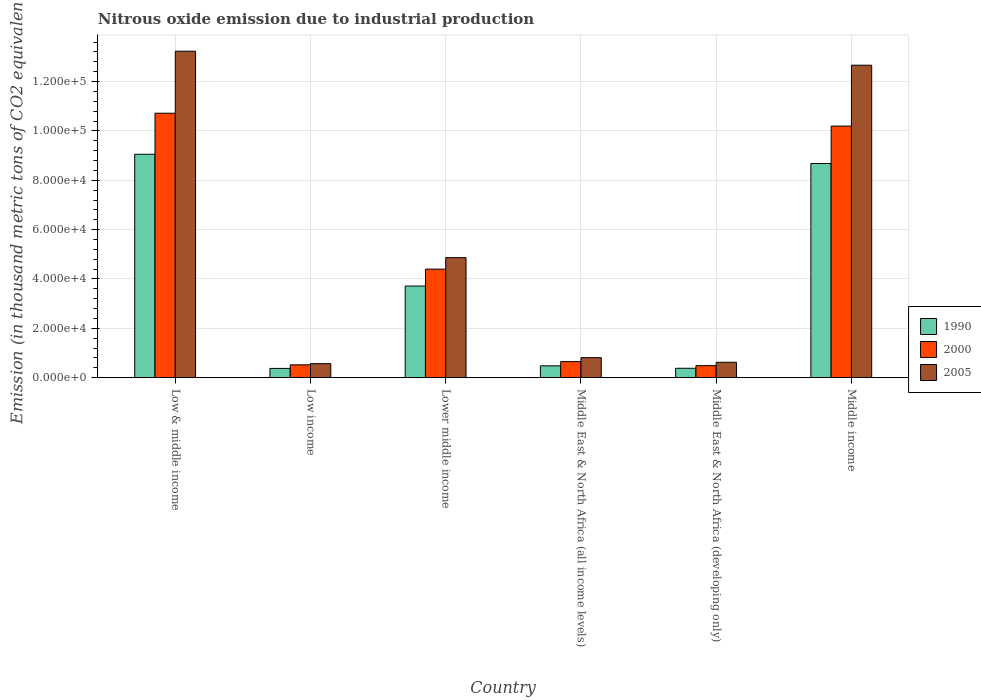Are the number of bars per tick equal to the number of legend labels?
Your answer should be compact. Yes. Are the number of bars on each tick of the X-axis equal?
Your answer should be compact. Yes. How many bars are there on the 5th tick from the left?
Make the answer very short. 3. What is the label of the 2nd group of bars from the left?
Offer a very short reply. Low income. In how many cases, is the number of bars for a given country not equal to the number of legend labels?
Your answer should be very brief. 0. What is the amount of nitrous oxide emitted in 2000 in Low & middle income?
Ensure brevity in your answer.  1.07e+05. Across all countries, what is the maximum amount of nitrous oxide emitted in 1990?
Your answer should be compact. 9.05e+04. Across all countries, what is the minimum amount of nitrous oxide emitted in 2005?
Offer a terse response. 5680.8. In which country was the amount of nitrous oxide emitted in 2000 minimum?
Provide a succinct answer. Middle East & North Africa (developing only). What is the total amount of nitrous oxide emitted in 2000 in the graph?
Ensure brevity in your answer.  2.70e+05. What is the difference between the amount of nitrous oxide emitted in 2000 in Low & middle income and that in Middle East & North Africa (all income levels)?
Give a very brief answer. 1.01e+05. What is the difference between the amount of nitrous oxide emitted in 2000 in Middle East & North Africa (all income levels) and the amount of nitrous oxide emitted in 2005 in Lower middle income?
Your answer should be compact. -4.22e+04. What is the average amount of nitrous oxide emitted in 2005 per country?
Offer a very short reply. 5.46e+04. What is the difference between the amount of nitrous oxide emitted of/in 2000 and amount of nitrous oxide emitted of/in 1990 in Middle income?
Your answer should be very brief. 1.52e+04. What is the ratio of the amount of nitrous oxide emitted in 1990 in Low & middle income to that in Lower middle income?
Offer a very short reply. 2.44. What is the difference between the highest and the second highest amount of nitrous oxide emitted in 1990?
Ensure brevity in your answer.  3751.3. What is the difference between the highest and the lowest amount of nitrous oxide emitted in 1990?
Your answer should be very brief. 8.68e+04. Is the sum of the amount of nitrous oxide emitted in 1990 in Low & middle income and Middle East & North Africa (all income levels) greater than the maximum amount of nitrous oxide emitted in 2005 across all countries?
Offer a terse response. No. Is it the case that in every country, the sum of the amount of nitrous oxide emitted in 2000 and amount of nitrous oxide emitted in 2005 is greater than the amount of nitrous oxide emitted in 1990?
Ensure brevity in your answer.  Yes. How many bars are there?
Offer a very short reply. 18. Are all the bars in the graph horizontal?
Your answer should be compact. No. How many countries are there in the graph?
Offer a terse response. 6. What is the difference between two consecutive major ticks on the Y-axis?
Keep it short and to the point. 2.00e+04. Are the values on the major ticks of Y-axis written in scientific E-notation?
Provide a succinct answer. Yes. Does the graph contain grids?
Your answer should be very brief. Yes. Where does the legend appear in the graph?
Provide a succinct answer. Center right. How many legend labels are there?
Your answer should be very brief. 3. What is the title of the graph?
Keep it short and to the point. Nitrous oxide emission due to industrial production. Does "1970" appear as one of the legend labels in the graph?
Your answer should be compact. No. What is the label or title of the X-axis?
Keep it short and to the point. Country. What is the label or title of the Y-axis?
Your answer should be compact. Emission (in thousand metric tons of CO2 equivalent). What is the Emission (in thousand metric tons of CO2 equivalent) in 1990 in Low & middle income?
Give a very brief answer. 9.05e+04. What is the Emission (in thousand metric tons of CO2 equivalent) of 2000 in Low & middle income?
Provide a succinct answer. 1.07e+05. What is the Emission (in thousand metric tons of CO2 equivalent) in 2005 in Low & middle income?
Give a very brief answer. 1.32e+05. What is the Emission (in thousand metric tons of CO2 equivalent) of 1990 in Low income?
Provide a succinct answer. 3751.3. What is the Emission (in thousand metric tons of CO2 equivalent) of 2000 in Low income?
Provide a short and direct response. 5201.5. What is the Emission (in thousand metric tons of CO2 equivalent) in 2005 in Low income?
Offer a terse response. 5680.8. What is the Emission (in thousand metric tons of CO2 equivalent) in 1990 in Lower middle income?
Provide a succinct answer. 3.71e+04. What is the Emission (in thousand metric tons of CO2 equivalent) of 2000 in Lower middle income?
Offer a terse response. 4.40e+04. What is the Emission (in thousand metric tons of CO2 equivalent) in 2005 in Lower middle income?
Provide a short and direct response. 4.87e+04. What is the Emission (in thousand metric tons of CO2 equivalent) in 1990 in Middle East & North Africa (all income levels)?
Make the answer very short. 4795.2. What is the Emission (in thousand metric tons of CO2 equivalent) of 2000 in Middle East & North Africa (all income levels)?
Your answer should be very brief. 6497. What is the Emission (in thousand metric tons of CO2 equivalent) of 2005 in Middle East & North Africa (all income levels)?
Your answer should be compact. 8118.6. What is the Emission (in thousand metric tons of CO2 equivalent) in 1990 in Middle East & North Africa (developing only)?
Keep it short and to the point. 3806.6. What is the Emission (in thousand metric tons of CO2 equivalent) in 2000 in Middle East & North Africa (developing only)?
Your response must be concise. 4882.9. What is the Emission (in thousand metric tons of CO2 equivalent) of 2005 in Middle East & North Africa (developing only)?
Your answer should be very brief. 6239.6. What is the Emission (in thousand metric tons of CO2 equivalent) in 1990 in Middle income?
Your answer should be very brief. 8.68e+04. What is the Emission (in thousand metric tons of CO2 equivalent) in 2000 in Middle income?
Provide a succinct answer. 1.02e+05. What is the Emission (in thousand metric tons of CO2 equivalent) of 2005 in Middle income?
Ensure brevity in your answer.  1.27e+05. Across all countries, what is the maximum Emission (in thousand metric tons of CO2 equivalent) of 1990?
Your answer should be compact. 9.05e+04. Across all countries, what is the maximum Emission (in thousand metric tons of CO2 equivalent) of 2000?
Keep it short and to the point. 1.07e+05. Across all countries, what is the maximum Emission (in thousand metric tons of CO2 equivalent) of 2005?
Your answer should be compact. 1.32e+05. Across all countries, what is the minimum Emission (in thousand metric tons of CO2 equivalent) of 1990?
Keep it short and to the point. 3751.3. Across all countries, what is the minimum Emission (in thousand metric tons of CO2 equivalent) of 2000?
Give a very brief answer. 4882.9. Across all countries, what is the minimum Emission (in thousand metric tons of CO2 equivalent) in 2005?
Make the answer very short. 5680.8. What is the total Emission (in thousand metric tons of CO2 equivalent) in 1990 in the graph?
Offer a terse response. 2.27e+05. What is the total Emission (in thousand metric tons of CO2 equivalent) of 2000 in the graph?
Give a very brief answer. 2.70e+05. What is the total Emission (in thousand metric tons of CO2 equivalent) in 2005 in the graph?
Keep it short and to the point. 3.28e+05. What is the difference between the Emission (in thousand metric tons of CO2 equivalent) in 1990 in Low & middle income and that in Low income?
Your answer should be compact. 8.68e+04. What is the difference between the Emission (in thousand metric tons of CO2 equivalent) in 2000 in Low & middle income and that in Low income?
Your answer should be compact. 1.02e+05. What is the difference between the Emission (in thousand metric tons of CO2 equivalent) in 2005 in Low & middle income and that in Low income?
Offer a very short reply. 1.27e+05. What is the difference between the Emission (in thousand metric tons of CO2 equivalent) in 1990 in Low & middle income and that in Lower middle income?
Your answer should be very brief. 5.34e+04. What is the difference between the Emission (in thousand metric tons of CO2 equivalent) of 2000 in Low & middle income and that in Lower middle income?
Provide a short and direct response. 6.32e+04. What is the difference between the Emission (in thousand metric tons of CO2 equivalent) in 2005 in Low & middle income and that in Lower middle income?
Your response must be concise. 8.37e+04. What is the difference between the Emission (in thousand metric tons of CO2 equivalent) in 1990 in Low & middle income and that in Middle East & North Africa (all income levels)?
Offer a very short reply. 8.57e+04. What is the difference between the Emission (in thousand metric tons of CO2 equivalent) of 2000 in Low & middle income and that in Middle East & North Africa (all income levels)?
Your answer should be compact. 1.01e+05. What is the difference between the Emission (in thousand metric tons of CO2 equivalent) in 2005 in Low & middle income and that in Middle East & North Africa (all income levels)?
Provide a succinct answer. 1.24e+05. What is the difference between the Emission (in thousand metric tons of CO2 equivalent) in 1990 in Low & middle income and that in Middle East & North Africa (developing only)?
Your response must be concise. 8.67e+04. What is the difference between the Emission (in thousand metric tons of CO2 equivalent) in 2000 in Low & middle income and that in Middle East & North Africa (developing only)?
Provide a short and direct response. 1.02e+05. What is the difference between the Emission (in thousand metric tons of CO2 equivalent) of 2005 in Low & middle income and that in Middle East & North Africa (developing only)?
Your response must be concise. 1.26e+05. What is the difference between the Emission (in thousand metric tons of CO2 equivalent) in 1990 in Low & middle income and that in Middle income?
Ensure brevity in your answer.  3751.3. What is the difference between the Emission (in thousand metric tons of CO2 equivalent) in 2000 in Low & middle income and that in Middle income?
Offer a terse response. 5201.5. What is the difference between the Emission (in thousand metric tons of CO2 equivalent) of 2005 in Low & middle income and that in Middle income?
Provide a succinct answer. 5680.8. What is the difference between the Emission (in thousand metric tons of CO2 equivalent) of 1990 in Low income and that in Lower middle income?
Make the answer very short. -3.34e+04. What is the difference between the Emission (in thousand metric tons of CO2 equivalent) in 2000 in Low income and that in Lower middle income?
Ensure brevity in your answer.  -3.88e+04. What is the difference between the Emission (in thousand metric tons of CO2 equivalent) in 2005 in Low income and that in Lower middle income?
Offer a terse response. -4.30e+04. What is the difference between the Emission (in thousand metric tons of CO2 equivalent) of 1990 in Low income and that in Middle East & North Africa (all income levels)?
Make the answer very short. -1043.9. What is the difference between the Emission (in thousand metric tons of CO2 equivalent) of 2000 in Low income and that in Middle East & North Africa (all income levels)?
Give a very brief answer. -1295.5. What is the difference between the Emission (in thousand metric tons of CO2 equivalent) in 2005 in Low income and that in Middle East & North Africa (all income levels)?
Your response must be concise. -2437.8. What is the difference between the Emission (in thousand metric tons of CO2 equivalent) of 1990 in Low income and that in Middle East & North Africa (developing only)?
Make the answer very short. -55.3. What is the difference between the Emission (in thousand metric tons of CO2 equivalent) of 2000 in Low income and that in Middle East & North Africa (developing only)?
Offer a terse response. 318.6. What is the difference between the Emission (in thousand metric tons of CO2 equivalent) in 2005 in Low income and that in Middle East & North Africa (developing only)?
Provide a short and direct response. -558.8. What is the difference between the Emission (in thousand metric tons of CO2 equivalent) in 1990 in Low income and that in Middle income?
Provide a short and direct response. -8.30e+04. What is the difference between the Emission (in thousand metric tons of CO2 equivalent) in 2000 in Low income and that in Middle income?
Ensure brevity in your answer.  -9.68e+04. What is the difference between the Emission (in thousand metric tons of CO2 equivalent) in 2005 in Low income and that in Middle income?
Keep it short and to the point. -1.21e+05. What is the difference between the Emission (in thousand metric tons of CO2 equivalent) of 1990 in Lower middle income and that in Middle East & North Africa (all income levels)?
Ensure brevity in your answer.  3.23e+04. What is the difference between the Emission (in thousand metric tons of CO2 equivalent) of 2000 in Lower middle income and that in Middle East & North Africa (all income levels)?
Your answer should be compact. 3.75e+04. What is the difference between the Emission (in thousand metric tons of CO2 equivalent) in 2005 in Lower middle income and that in Middle East & North Africa (all income levels)?
Keep it short and to the point. 4.05e+04. What is the difference between the Emission (in thousand metric tons of CO2 equivalent) of 1990 in Lower middle income and that in Middle East & North Africa (developing only)?
Offer a terse response. 3.33e+04. What is the difference between the Emission (in thousand metric tons of CO2 equivalent) of 2000 in Lower middle income and that in Middle East & North Africa (developing only)?
Ensure brevity in your answer.  3.91e+04. What is the difference between the Emission (in thousand metric tons of CO2 equivalent) of 2005 in Lower middle income and that in Middle East & North Africa (developing only)?
Provide a short and direct response. 4.24e+04. What is the difference between the Emission (in thousand metric tons of CO2 equivalent) in 1990 in Lower middle income and that in Middle income?
Your response must be concise. -4.97e+04. What is the difference between the Emission (in thousand metric tons of CO2 equivalent) in 2000 in Lower middle income and that in Middle income?
Provide a short and direct response. -5.80e+04. What is the difference between the Emission (in thousand metric tons of CO2 equivalent) of 2005 in Lower middle income and that in Middle income?
Offer a terse response. -7.80e+04. What is the difference between the Emission (in thousand metric tons of CO2 equivalent) in 1990 in Middle East & North Africa (all income levels) and that in Middle East & North Africa (developing only)?
Your answer should be very brief. 988.6. What is the difference between the Emission (in thousand metric tons of CO2 equivalent) of 2000 in Middle East & North Africa (all income levels) and that in Middle East & North Africa (developing only)?
Your answer should be compact. 1614.1. What is the difference between the Emission (in thousand metric tons of CO2 equivalent) in 2005 in Middle East & North Africa (all income levels) and that in Middle East & North Africa (developing only)?
Your answer should be compact. 1879. What is the difference between the Emission (in thousand metric tons of CO2 equivalent) in 1990 in Middle East & North Africa (all income levels) and that in Middle income?
Provide a succinct answer. -8.20e+04. What is the difference between the Emission (in thousand metric tons of CO2 equivalent) of 2000 in Middle East & North Africa (all income levels) and that in Middle income?
Your answer should be compact. -9.55e+04. What is the difference between the Emission (in thousand metric tons of CO2 equivalent) in 2005 in Middle East & North Africa (all income levels) and that in Middle income?
Provide a succinct answer. -1.19e+05. What is the difference between the Emission (in thousand metric tons of CO2 equivalent) in 1990 in Middle East & North Africa (developing only) and that in Middle income?
Keep it short and to the point. -8.30e+04. What is the difference between the Emission (in thousand metric tons of CO2 equivalent) in 2000 in Middle East & North Africa (developing only) and that in Middle income?
Give a very brief answer. -9.71e+04. What is the difference between the Emission (in thousand metric tons of CO2 equivalent) of 2005 in Middle East & North Africa (developing only) and that in Middle income?
Make the answer very short. -1.20e+05. What is the difference between the Emission (in thousand metric tons of CO2 equivalent) in 1990 in Low & middle income and the Emission (in thousand metric tons of CO2 equivalent) in 2000 in Low income?
Ensure brevity in your answer.  8.53e+04. What is the difference between the Emission (in thousand metric tons of CO2 equivalent) in 1990 in Low & middle income and the Emission (in thousand metric tons of CO2 equivalent) in 2005 in Low income?
Make the answer very short. 8.49e+04. What is the difference between the Emission (in thousand metric tons of CO2 equivalent) of 2000 in Low & middle income and the Emission (in thousand metric tons of CO2 equivalent) of 2005 in Low income?
Provide a succinct answer. 1.01e+05. What is the difference between the Emission (in thousand metric tons of CO2 equivalent) of 1990 in Low & middle income and the Emission (in thousand metric tons of CO2 equivalent) of 2000 in Lower middle income?
Offer a very short reply. 4.66e+04. What is the difference between the Emission (in thousand metric tons of CO2 equivalent) of 1990 in Low & middle income and the Emission (in thousand metric tons of CO2 equivalent) of 2005 in Lower middle income?
Your answer should be compact. 4.19e+04. What is the difference between the Emission (in thousand metric tons of CO2 equivalent) of 2000 in Low & middle income and the Emission (in thousand metric tons of CO2 equivalent) of 2005 in Lower middle income?
Your answer should be very brief. 5.85e+04. What is the difference between the Emission (in thousand metric tons of CO2 equivalent) in 1990 in Low & middle income and the Emission (in thousand metric tons of CO2 equivalent) in 2000 in Middle East & North Africa (all income levels)?
Offer a very short reply. 8.40e+04. What is the difference between the Emission (in thousand metric tons of CO2 equivalent) in 1990 in Low & middle income and the Emission (in thousand metric tons of CO2 equivalent) in 2005 in Middle East & North Africa (all income levels)?
Provide a succinct answer. 8.24e+04. What is the difference between the Emission (in thousand metric tons of CO2 equivalent) of 2000 in Low & middle income and the Emission (in thousand metric tons of CO2 equivalent) of 2005 in Middle East & North Africa (all income levels)?
Provide a succinct answer. 9.90e+04. What is the difference between the Emission (in thousand metric tons of CO2 equivalent) of 1990 in Low & middle income and the Emission (in thousand metric tons of CO2 equivalent) of 2000 in Middle East & North Africa (developing only)?
Ensure brevity in your answer.  8.57e+04. What is the difference between the Emission (in thousand metric tons of CO2 equivalent) in 1990 in Low & middle income and the Emission (in thousand metric tons of CO2 equivalent) in 2005 in Middle East & North Africa (developing only)?
Give a very brief answer. 8.43e+04. What is the difference between the Emission (in thousand metric tons of CO2 equivalent) in 2000 in Low & middle income and the Emission (in thousand metric tons of CO2 equivalent) in 2005 in Middle East & North Africa (developing only)?
Your answer should be very brief. 1.01e+05. What is the difference between the Emission (in thousand metric tons of CO2 equivalent) of 1990 in Low & middle income and the Emission (in thousand metric tons of CO2 equivalent) of 2000 in Middle income?
Make the answer very short. -1.14e+04. What is the difference between the Emission (in thousand metric tons of CO2 equivalent) in 1990 in Low & middle income and the Emission (in thousand metric tons of CO2 equivalent) in 2005 in Middle income?
Your answer should be compact. -3.61e+04. What is the difference between the Emission (in thousand metric tons of CO2 equivalent) in 2000 in Low & middle income and the Emission (in thousand metric tons of CO2 equivalent) in 2005 in Middle income?
Your response must be concise. -1.95e+04. What is the difference between the Emission (in thousand metric tons of CO2 equivalent) in 1990 in Low income and the Emission (in thousand metric tons of CO2 equivalent) in 2000 in Lower middle income?
Your answer should be compact. -4.02e+04. What is the difference between the Emission (in thousand metric tons of CO2 equivalent) of 1990 in Low income and the Emission (in thousand metric tons of CO2 equivalent) of 2005 in Lower middle income?
Ensure brevity in your answer.  -4.49e+04. What is the difference between the Emission (in thousand metric tons of CO2 equivalent) of 2000 in Low income and the Emission (in thousand metric tons of CO2 equivalent) of 2005 in Lower middle income?
Your response must be concise. -4.35e+04. What is the difference between the Emission (in thousand metric tons of CO2 equivalent) in 1990 in Low income and the Emission (in thousand metric tons of CO2 equivalent) in 2000 in Middle East & North Africa (all income levels)?
Offer a terse response. -2745.7. What is the difference between the Emission (in thousand metric tons of CO2 equivalent) of 1990 in Low income and the Emission (in thousand metric tons of CO2 equivalent) of 2005 in Middle East & North Africa (all income levels)?
Your answer should be compact. -4367.3. What is the difference between the Emission (in thousand metric tons of CO2 equivalent) in 2000 in Low income and the Emission (in thousand metric tons of CO2 equivalent) in 2005 in Middle East & North Africa (all income levels)?
Provide a succinct answer. -2917.1. What is the difference between the Emission (in thousand metric tons of CO2 equivalent) in 1990 in Low income and the Emission (in thousand metric tons of CO2 equivalent) in 2000 in Middle East & North Africa (developing only)?
Provide a short and direct response. -1131.6. What is the difference between the Emission (in thousand metric tons of CO2 equivalent) in 1990 in Low income and the Emission (in thousand metric tons of CO2 equivalent) in 2005 in Middle East & North Africa (developing only)?
Give a very brief answer. -2488.3. What is the difference between the Emission (in thousand metric tons of CO2 equivalent) in 2000 in Low income and the Emission (in thousand metric tons of CO2 equivalent) in 2005 in Middle East & North Africa (developing only)?
Make the answer very short. -1038.1. What is the difference between the Emission (in thousand metric tons of CO2 equivalent) in 1990 in Low income and the Emission (in thousand metric tons of CO2 equivalent) in 2000 in Middle income?
Give a very brief answer. -9.82e+04. What is the difference between the Emission (in thousand metric tons of CO2 equivalent) of 1990 in Low income and the Emission (in thousand metric tons of CO2 equivalent) of 2005 in Middle income?
Make the answer very short. -1.23e+05. What is the difference between the Emission (in thousand metric tons of CO2 equivalent) in 2000 in Low income and the Emission (in thousand metric tons of CO2 equivalent) in 2005 in Middle income?
Offer a very short reply. -1.21e+05. What is the difference between the Emission (in thousand metric tons of CO2 equivalent) of 1990 in Lower middle income and the Emission (in thousand metric tons of CO2 equivalent) of 2000 in Middle East & North Africa (all income levels)?
Provide a short and direct response. 3.06e+04. What is the difference between the Emission (in thousand metric tons of CO2 equivalent) of 1990 in Lower middle income and the Emission (in thousand metric tons of CO2 equivalent) of 2005 in Middle East & North Africa (all income levels)?
Your answer should be very brief. 2.90e+04. What is the difference between the Emission (in thousand metric tons of CO2 equivalent) in 2000 in Lower middle income and the Emission (in thousand metric tons of CO2 equivalent) in 2005 in Middle East & North Africa (all income levels)?
Your response must be concise. 3.59e+04. What is the difference between the Emission (in thousand metric tons of CO2 equivalent) of 1990 in Lower middle income and the Emission (in thousand metric tons of CO2 equivalent) of 2000 in Middle East & North Africa (developing only)?
Ensure brevity in your answer.  3.22e+04. What is the difference between the Emission (in thousand metric tons of CO2 equivalent) in 1990 in Lower middle income and the Emission (in thousand metric tons of CO2 equivalent) in 2005 in Middle East & North Africa (developing only)?
Keep it short and to the point. 3.09e+04. What is the difference between the Emission (in thousand metric tons of CO2 equivalent) in 2000 in Lower middle income and the Emission (in thousand metric tons of CO2 equivalent) in 2005 in Middle East & North Africa (developing only)?
Ensure brevity in your answer.  3.77e+04. What is the difference between the Emission (in thousand metric tons of CO2 equivalent) of 1990 in Lower middle income and the Emission (in thousand metric tons of CO2 equivalent) of 2000 in Middle income?
Keep it short and to the point. -6.48e+04. What is the difference between the Emission (in thousand metric tons of CO2 equivalent) of 1990 in Lower middle income and the Emission (in thousand metric tons of CO2 equivalent) of 2005 in Middle income?
Ensure brevity in your answer.  -8.95e+04. What is the difference between the Emission (in thousand metric tons of CO2 equivalent) of 2000 in Lower middle income and the Emission (in thousand metric tons of CO2 equivalent) of 2005 in Middle income?
Provide a succinct answer. -8.26e+04. What is the difference between the Emission (in thousand metric tons of CO2 equivalent) of 1990 in Middle East & North Africa (all income levels) and the Emission (in thousand metric tons of CO2 equivalent) of 2000 in Middle East & North Africa (developing only)?
Keep it short and to the point. -87.7. What is the difference between the Emission (in thousand metric tons of CO2 equivalent) in 1990 in Middle East & North Africa (all income levels) and the Emission (in thousand metric tons of CO2 equivalent) in 2005 in Middle East & North Africa (developing only)?
Ensure brevity in your answer.  -1444.4. What is the difference between the Emission (in thousand metric tons of CO2 equivalent) of 2000 in Middle East & North Africa (all income levels) and the Emission (in thousand metric tons of CO2 equivalent) of 2005 in Middle East & North Africa (developing only)?
Provide a short and direct response. 257.4. What is the difference between the Emission (in thousand metric tons of CO2 equivalent) in 1990 in Middle East & North Africa (all income levels) and the Emission (in thousand metric tons of CO2 equivalent) in 2000 in Middle income?
Your answer should be compact. -9.72e+04. What is the difference between the Emission (in thousand metric tons of CO2 equivalent) in 1990 in Middle East & North Africa (all income levels) and the Emission (in thousand metric tons of CO2 equivalent) in 2005 in Middle income?
Ensure brevity in your answer.  -1.22e+05. What is the difference between the Emission (in thousand metric tons of CO2 equivalent) in 2000 in Middle East & North Africa (all income levels) and the Emission (in thousand metric tons of CO2 equivalent) in 2005 in Middle income?
Keep it short and to the point. -1.20e+05. What is the difference between the Emission (in thousand metric tons of CO2 equivalent) in 1990 in Middle East & North Africa (developing only) and the Emission (in thousand metric tons of CO2 equivalent) in 2000 in Middle income?
Your answer should be very brief. -9.82e+04. What is the difference between the Emission (in thousand metric tons of CO2 equivalent) of 1990 in Middle East & North Africa (developing only) and the Emission (in thousand metric tons of CO2 equivalent) of 2005 in Middle income?
Ensure brevity in your answer.  -1.23e+05. What is the difference between the Emission (in thousand metric tons of CO2 equivalent) in 2000 in Middle East & North Africa (developing only) and the Emission (in thousand metric tons of CO2 equivalent) in 2005 in Middle income?
Your answer should be very brief. -1.22e+05. What is the average Emission (in thousand metric tons of CO2 equivalent) of 1990 per country?
Keep it short and to the point. 3.78e+04. What is the average Emission (in thousand metric tons of CO2 equivalent) in 2000 per country?
Offer a very short reply. 4.49e+04. What is the average Emission (in thousand metric tons of CO2 equivalent) of 2005 per country?
Your response must be concise. 5.46e+04. What is the difference between the Emission (in thousand metric tons of CO2 equivalent) of 1990 and Emission (in thousand metric tons of CO2 equivalent) of 2000 in Low & middle income?
Make the answer very short. -1.66e+04. What is the difference between the Emission (in thousand metric tons of CO2 equivalent) in 1990 and Emission (in thousand metric tons of CO2 equivalent) in 2005 in Low & middle income?
Offer a very short reply. -4.18e+04. What is the difference between the Emission (in thousand metric tons of CO2 equivalent) of 2000 and Emission (in thousand metric tons of CO2 equivalent) of 2005 in Low & middle income?
Your response must be concise. -2.51e+04. What is the difference between the Emission (in thousand metric tons of CO2 equivalent) of 1990 and Emission (in thousand metric tons of CO2 equivalent) of 2000 in Low income?
Your answer should be very brief. -1450.2. What is the difference between the Emission (in thousand metric tons of CO2 equivalent) of 1990 and Emission (in thousand metric tons of CO2 equivalent) of 2005 in Low income?
Ensure brevity in your answer.  -1929.5. What is the difference between the Emission (in thousand metric tons of CO2 equivalent) in 2000 and Emission (in thousand metric tons of CO2 equivalent) in 2005 in Low income?
Give a very brief answer. -479.3. What is the difference between the Emission (in thousand metric tons of CO2 equivalent) in 1990 and Emission (in thousand metric tons of CO2 equivalent) in 2000 in Lower middle income?
Ensure brevity in your answer.  -6854.5. What is the difference between the Emission (in thousand metric tons of CO2 equivalent) of 1990 and Emission (in thousand metric tons of CO2 equivalent) of 2005 in Lower middle income?
Your answer should be very brief. -1.15e+04. What is the difference between the Emission (in thousand metric tons of CO2 equivalent) of 2000 and Emission (in thousand metric tons of CO2 equivalent) of 2005 in Lower middle income?
Give a very brief answer. -4665.5. What is the difference between the Emission (in thousand metric tons of CO2 equivalent) in 1990 and Emission (in thousand metric tons of CO2 equivalent) in 2000 in Middle East & North Africa (all income levels)?
Offer a very short reply. -1701.8. What is the difference between the Emission (in thousand metric tons of CO2 equivalent) of 1990 and Emission (in thousand metric tons of CO2 equivalent) of 2005 in Middle East & North Africa (all income levels)?
Provide a short and direct response. -3323.4. What is the difference between the Emission (in thousand metric tons of CO2 equivalent) in 2000 and Emission (in thousand metric tons of CO2 equivalent) in 2005 in Middle East & North Africa (all income levels)?
Your answer should be very brief. -1621.6. What is the difference between the Emission (in thousand metric tons of CO2 equivalent) in 1990 and Emission (in thousand metric tons of CO2 equivalent) in 2000 in Middle East & North Africa (developing only)?
Your response must be concise. -1076.3. What is the difference between the Emission (in thousand metric tons of CO2 equivalent) in 1990 and Emission (in thousand metric tons of CO2 equivalent) in 2005 in Middle East & North Africa (developing only)?
Your answer should be very brief. -2433. What is the difference between the Emission (in thousand metric tons of CO2 equivalent) of 2000 and Emission (in thousand metric tons of CO2 equivalent) of 2005 in Middle East & North Africa (developing only)?
Your answer should be compact. -1356.7. What is the difference between the Emission (in thousand metric tons of CO2 equivalent) in 1990 and Emission (in thousand metric tons of CO2 equivalent) in 2000 in Middle income?
Your answer should be compact. -1.52e+04. What is the difference between the Emission (in thousand metric tons of CO2 equivalent) of 1990 and Emission (in thousand metric tons of CO2 equivalent) of 2005 in Middle income?
Your answer should be very brief. -3.98e+04. What is the difference between the Emission (in thousand metric tons of CO2 equivalent) in 2000 and Emission (in thousand metric tons of CO2 equivalent) in 2005 in Middle income?
Your answer should be compact. -2.47e+04. What is the ratio of the Emission (in thousand metric tons of CO2 equivalent) in 1990 in Low & middle income to that in Low income?
Ensure brevity in your answer.  24.14. What is the ratio of the Emission (in thousand metric tons of CO2 equivalent) of 2000 in Low & middle income to that in Low income?
Give a very brief answer. 20.6. What is the ratio of the Emission (in thousand metric tons of CO2 equivalent) in 2005 in Low & middle income to that in Low income?
Offer a terse response. 23.29. What is the ratio of the Emission (in thousand metric tons of CO2 equivalent) of 1990 in Low & middle income to that in Lower middle income?
Provide a succinct answer. 2.44. What is the ratio of the Emission (in thousand metric tons of CO2 equivalent) of 2000 in Low & middle income to that in Lower middle income?
Your response must be concise. 2.44. What is the ratio of the Emission (in thousand metric tons of CO2 equivalent) in 2005 in Low & middle income to that in Lower middle income?
Ensure brevity in your answer.  2.72. What is the ratio of the Emission (in thousand metric tons of CO2 equivalent) in 1990 in Low & middle income to that in Middle East & North Africa (all income levels)?
Your answer should be compact. 18.88. What is the ratio of the Emission (in thousand metric tons of CO2 equivalent) of 2000 in Low & middle income to that in Middle East & North Africa (all income levels)?
Your answer should be very brief. 16.49. What is the ratio of the Emission (in thousand metric tons of CO2 equivalent) in 2005 in Low & middle income to that in Middle East & North Africa (all income levels)?
Offer a terse response. 16.3. What is the ratio of the Emission (in thousand metric tons of CO2 equivalent) in 1990 in Low & middle income to that in Middle East & North Africa (developing only)?
Provide a short and direct response. 23.78. What is the ratio of the Emission (in thousand metric tons of CO2 equivalent) in 2000 in Low & middle income to that in Middle East & North Africa (developing only)?
Offer a very short reply. 21.95. What is the ratio of the Emission (in thousand metric tons of CO2 equivalent) of 2005 in Low & middle income to that in Middle East & North Africa (developing only)?
Offer a very short reply. 21.2. What is the ratio of the Emission (in thousand metric tons of CO2 equivalent) of 1990 in Low & middle income to that in Middle income?
Keep it short and to the point. 1.04. What is the ratio of the Emission (in thousand metric tons of CO2 equivalent) of 2000 in Low & middle income to that in Middle income?
Ensure brevity in your answer.  1.05. What is the ratio of the Emission (in thousand metric tons of CO2 equivalent) in 2005 in Low & middle income to that in Middle income?
Offer a terse response. 1.04. What is the ratio of the Emission (in thousand metric tons of CO2 equivalent) in 1990 in Low income to that in Lower middle income?
Your answer should be compact. 0.1. What is the ratio of the Emission (in thousand metric tons of CO2 equivalent) in 2000 in Low income to that in Lower middle income?
Make the answer very short. 0.12. What is the ratio of the Emission (in thousand metric tons of CO2 equivalent) of 2005 in Low income to that in Lower middle income?
Ensure brevity in your answer.  0.12. What is the ratio of the Emission (in thousand metric tons of CO2 equivalent) of 1990 in Low income to that in Middle East & North Africa (all income levels)?
Provide a succinct answer. 0.78. What is the ratio of the Emission (in thousand metric tons of CO2 equivalent) in 2000 in Low income to that in Middle East & North Africa (all income levels)?
Your answer should be very brief. 0.8. What is the ratio of the Emission (in thousand metric tons of CO2 equivalent) of 2005 in Low income to that in Middle East & North Africa (all income levels)?
Your answer should be very brief. 0.7. What is the ratio of the Emission (in thousand metric tons of CO2 equivalent) of 1990 in Low income to that in Middle East & North Africa (developing only)?
Your response must be concise. 0.99. What is the ratio of the Emission (in thousand metric tons of CO2 equivalent) in 2000 in Low income to that in Middle East & North Africa (developing only)?
Your response must be concise. 1.07. What is the ratio of the Emission (in thousand metric tons of CO2 equivalent) of 2005 in Low income to that in Middle East & North Africa (developing only)?
Ensure brevity in your answer.  0.91. What is the ratio of the Emission (in thousand metric tons of CO2 equivalent) in 1990 in Low income to that in Middle income?
Offer a terse response. 0.04. What is the ratio of the Emission (in thousand metric tons of CO2 equivalent) of 2000 in Low income to that in Middle income?
Offer a terse response. 0.05. What is the ratio of the Emission (in thousand metric tons of CO2 equivalent) in 2005 in Low income to that in Middle income?
Your answer should be compact. 0.04. What is the ratio of the Emission (in thousand metric tons of CO2 equivalent) of 1990 in Lower middle income to that in Middle East & North Africa (all income levels)?
Offer a very short reply. 7.74. What is the ratio of the Emission (in thousand metric tons of CO2 equivalent) in 2000 in Lower middle income to that in Middle East & North Africa (all income levels)?
Provide a short and direct response. 6.77. What is the ratio of the Emission (in thousand metric tons of CO2 equivalent) of 2005 in Lower middle income to that in Middle East & North Africa (all income levels)?
Your answer should be very brief. 5.99. What is the ratio of the Emission (in thousand metric tons of CO2 equivalent) of 1990 in Lower middle income to that in Middle East & North Africa (developing only)?
Ensure brevity in your answer.  9.75. What is the ratio of the Emission (in thousand metric tons of CO2 equivalent) of 2000 in Lower middle income to that in Middle East & North Africa (developing only)?
Your answer should be compact. 9.01. What is the ratio of the Emission (in thousand metric tons of CO2 equivalent) in 2005 in Lower middle income to that in Middle East & North Africa (developing only)?
Offer a very short reply. 7.8. What is the ratio of the Emission (in thousand metric tons of CO2 equivalent) in 1990 in Lower middle income to that in Middle income?
Your answer should be very brief. 0.43. What is the ratio of the Emission (in thousand metric tons of CO2 equivalent) of 2000 in Lower middle income to that in Middle income?
Offer a terse response. 0.43. What is the ratio of the Emission (in thousand metric tons of CO2 equivalent) of 2005 in Lower middle income to that in Middle income?
Your answer should be compact. 0.38. What is the ratio of the Emission (in thousand metric tons of CO2 equivalent) in 1990 in Middle East & North Africa (all income levels) to that in Middle East & North Africa (developing only)?
Offer a very short reply. 1.26. What is the ratio of the Emission (in thousand metric tons of CO2 equivalent) of 2000 in Middle East & North Africa (all income levels) to that in Middle East & North Africa (developing only)?
Make the answer very short. 1.33. What is the ratio of the Emission (in thousand metric tons of CO2 equivalent) in 2005 in Middle East & North Africa (all income levels) to that in Middle East & North Africa (developing only)?
Provide a succinct answer. 1.3. What is the ratio of the Emission (in thousand metric tons of CO2 equivalent) of 1990 in Middle East & North Africa (all income levels) to that in Middle income?
Give a very brief answer. 0.06. What is the ratio of the Emission (in thousand metric tons of CO2 equivalent) in 2000 in Middle East & North Africa (all income levels) to that in Middle income?
Offer a terse response. 0.06. What is the ratio of the Emission (in thousand metric tons of CO2 equivalent) of 2005 in Middle East & North Africa (all income levels) to that in Middle income?
Your answer should be very brief. 0.06. What is the ratio of the Emission (in thousand metric tons of CO2 equivalent) in 1990 in Middle East & North Africa (developing only) to that in Middle income?
Offer a terse response. 0.04. What is the ratio of the Emission (in thousand metric tons of CO2 equivalent) in 2000 in Middle East & North Africa (developing only) to that in Middle income?
Give a very brief answer. 0.05. What is the ratio of the Emission (in thousand metric tons of CO2 equivalent) in 2005 in Middle East & North Africa (developing only) to that in Middle income?
Make the answer very short. 0.05. What is the difference between the highest and the second highest Emission (in thousand metric tons of CO2 equivalent) in 1990?
Make the answer very short. 3751.3. What is the difference between the highest and the second highest Emission (in thousand metric tons of CO2 equivalent) in 2000?
Your answer should be compact. 5201.5. What is the difference between the highest and the second highest Emission (in thousand metric tons of CO2 equivalent) in 2005?
Make the answer very short. 5680.8. What is the difference between the highest and the lowest Emission (in thousand metric tons of CO2 equivalent) in 1990?
Keep it short and to the point. 8.68e+04. What is the difference between the highest and the lowest Emission (in thousand metric tons of CO2 equivalent) in 2000?
Offer a terse response. 1.02e+05. What is the difference between the highest and the lowest Emission (in thousand metric tons of CO2 equivalent) in 2005?
Make the answer very short. 1.27e+05. 